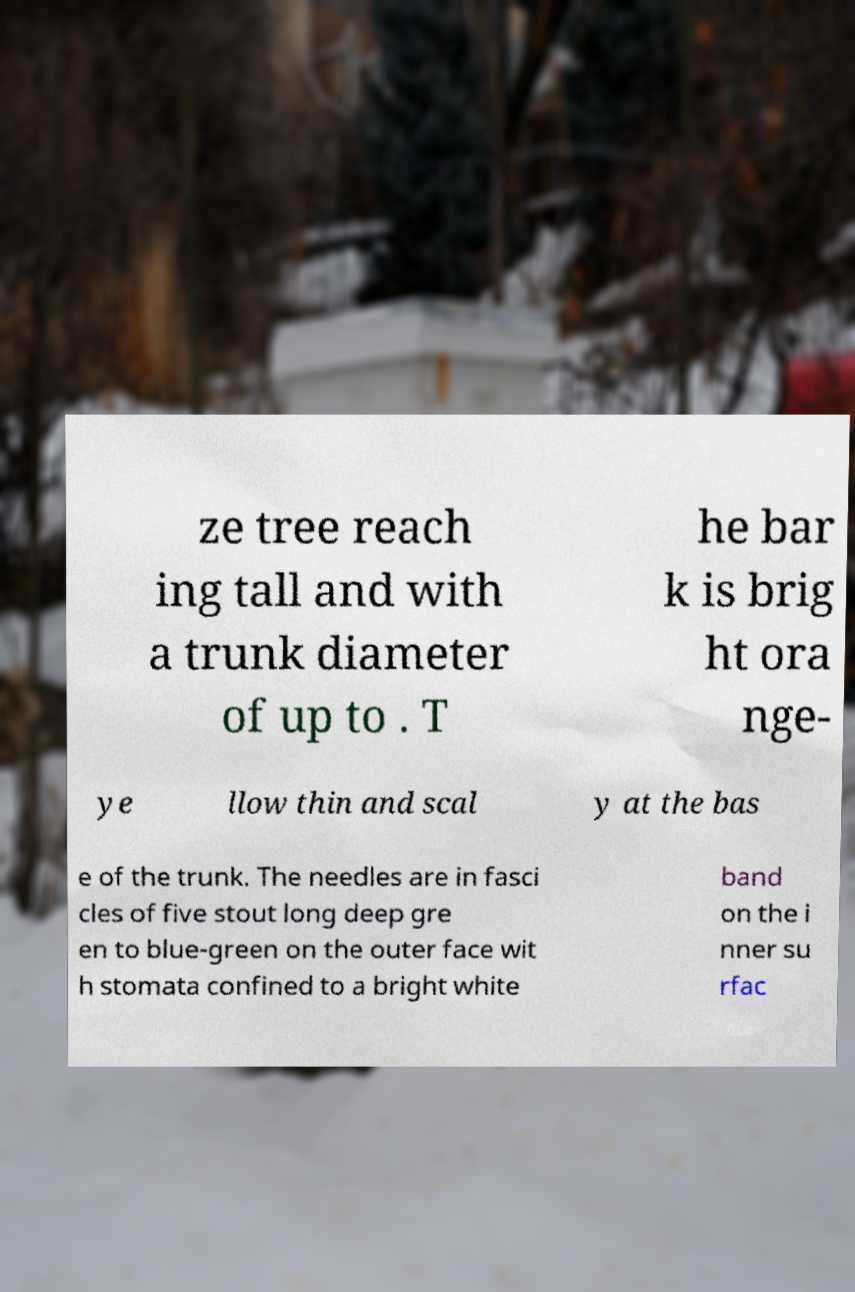Can you accurately transcribe the text from the provided image for me? ze tree reach ing tall and with a trunk diameter of up to . T he bar k is brig ht ora nge- ye llow thin and scal y at the bas e of the trunk. The needles are in fasci cles of five stout long deep gre en to blue-green on the outer face wit h stomata confined to a bright white band on the i nner su rfac 